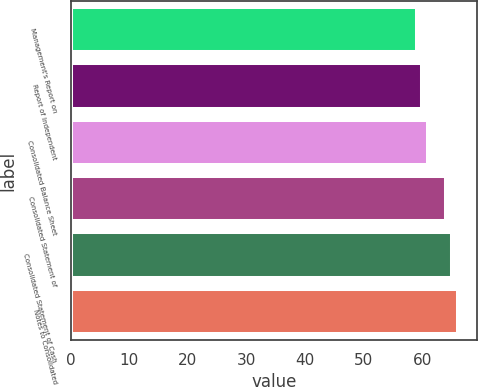Convert chart to OTSL. <chart><loc_0><loc_0><loc_500><loc_500><bar_chart><fcel>Management's Report on<fcel>Report of Independent<fcel>Consolidated Balance Sheet<fcel>Consolidated Statement of<fcel>Consolidated Statement of Cash<fcel>Notes to Consolidated<nl><fcel>59<fcel>60<fcel>61<fcel>64<fcel>65<fcel>66<nl></chart> 